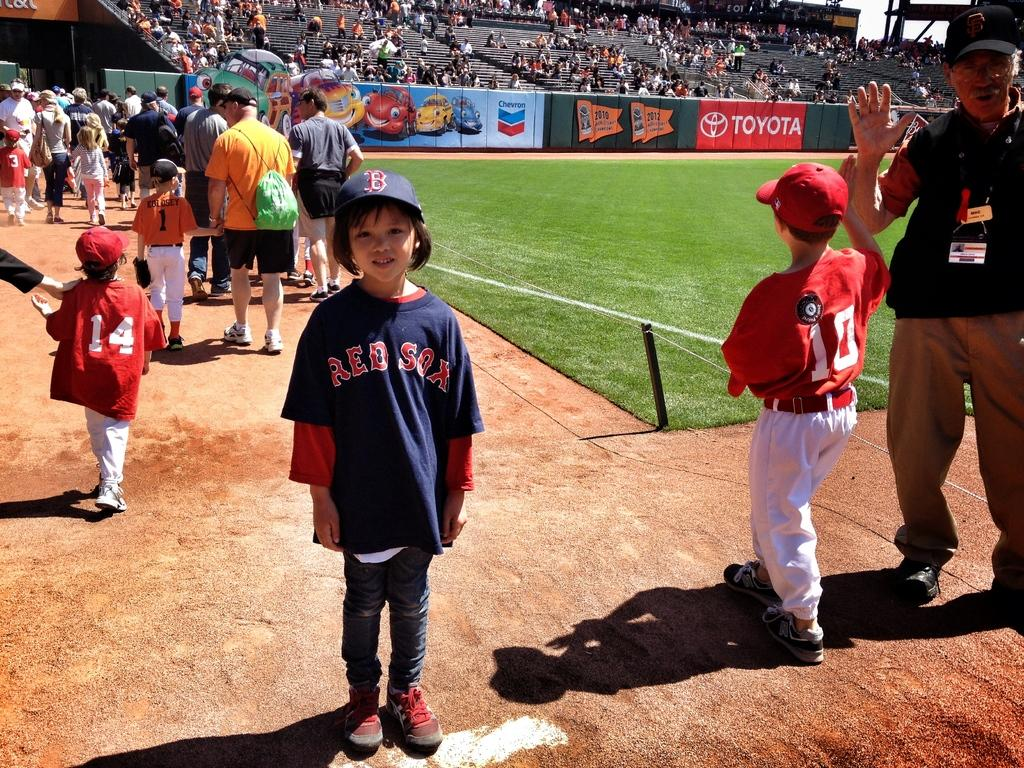Who is present in the image? There are persons and kids in the image. What are the persons and kids wearing? They are wearing clothes. How many people are in the image? There is a crowd in the image, which suggests a large number of people. What is visible at the top of the image? There is a wall at the top of the image. What type of mist can be seen in the image? There is no mist present in the image. Which direction is the crowd facing in the image? The direction the crowd is facing cannot be determined from the image. 